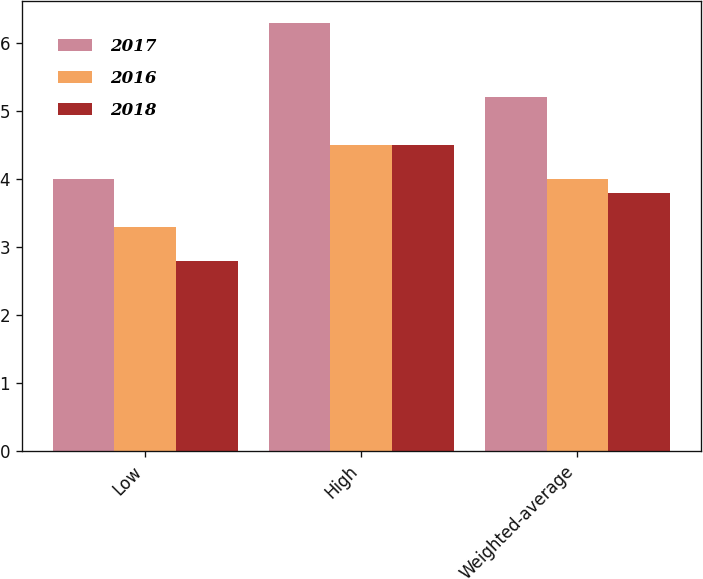Convert chart. <chart><loc_0><loc_0><loc_500><loc_500><stacked_bar_chart><ecel><fcel>Low<fcel>High<fcel>Weighted-average<nl><fcel>2017<fcel>4<fcel>6.3<fcel>5.2<nl><fcel>2016<fcel>3.3<fcel>4.5<fcel>4<nl><fcel>2018<fcel>2.8<fcel>4.5<fcel>3.8<nl></chart> 